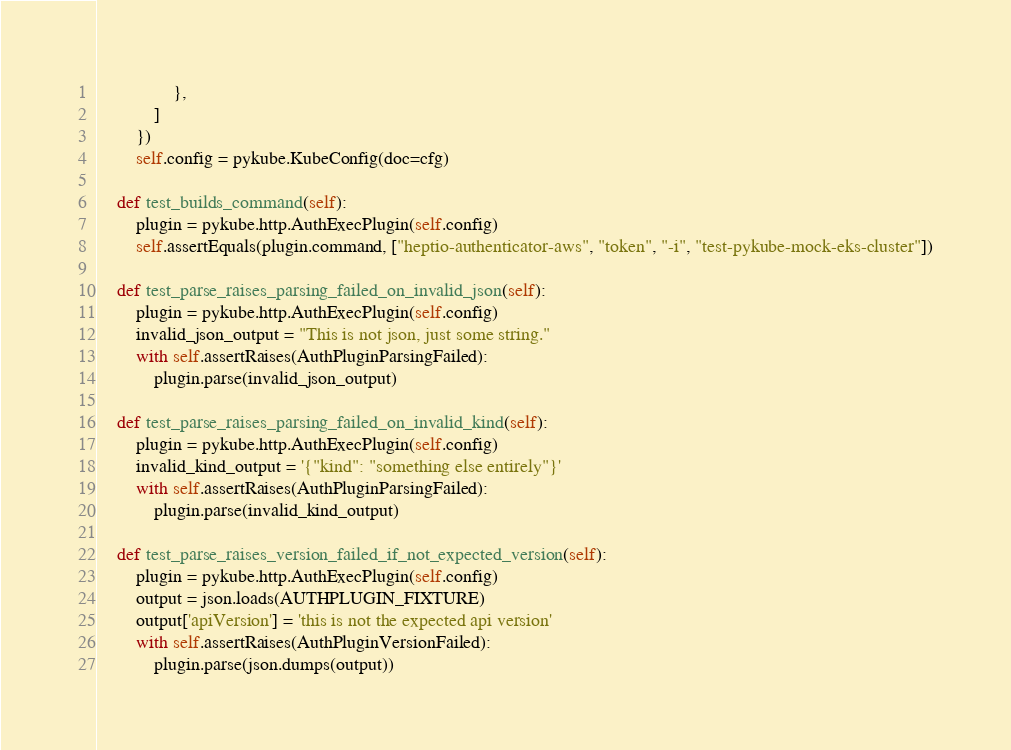<code> <loc_0><loc_0><loc_500><loc_500><_Python_>                },
            ]
        })
        self.config = pykube.KubeConfig(doc=cfg)

    def test_builds_command(self):
        plugin = pykube.http.AuthExecPlugin(self.config)
        self.assertEquals(plugin.command, ["heptio-authenticator-aws", "token", "-i", "test-pykube-mock-eks-cluster"])

    def test_parse_raises_parsing_failed_on_invalid_json(self):
        plugin = pykube.http.AuthExecPlugin(self.config)
        invalid_json_output = "This is not json, just some string."
        with self.assertRaises(AuthPluginParsingFailed):
            plugin.parse(invalid_json_output)

    def test_parse_raises_parsing_failed_on_invalid_kind(self):
        plugin = pykube.http.AuthExecPlugin(self.config)
        invalid_kind_output = '{"kind": "something else entirely"}'
        with self.assertRaises(AuthPluginParsingFailed):
            plugin.parse(invalid_kind_output)

    def test_parse_raises_version_failed_if_not_expected_version(self):
        plugin = pykube.http.AuthExecPlugin(self.config)
        output = json.loads(AUTHPLUGIN_FIXTURE)
        output['apiVersion'] = 'this is not the expected api version'
        with self.assertRaises(AuthPluginVersionFailed):
            plugin.parse(json.dumps(output))
</code> 